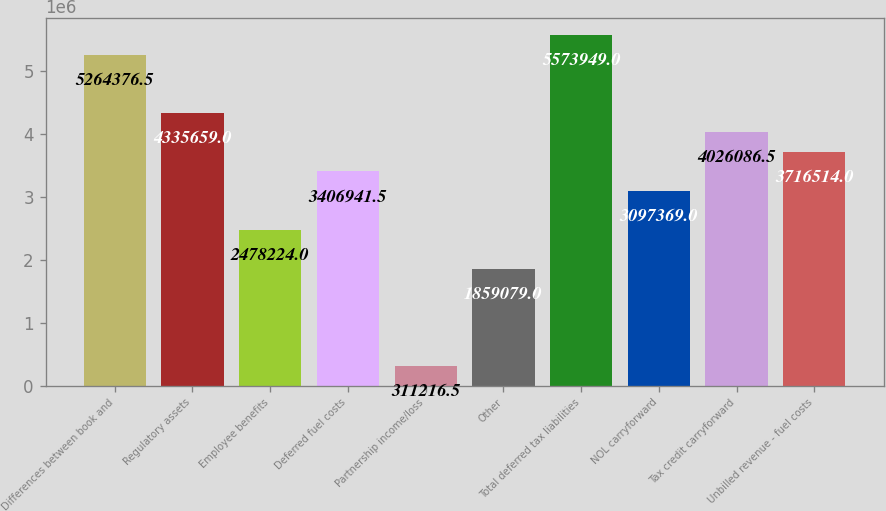Convert chart. <chart><loc_0><loc_0><loc_500><loc_500><bar_chart><fcel>Differences between book and<fcel>Regulatory assets<fcel>Employee benefits<fcel>Deferred fuel costs<fcel>Partnership income/loss<fcel>Other<fcel>Total deferred tax liabilities<fcel>NOL carryforward<fcel>Tax credit carryforward<fcel>Unbilled revenue - fuel costs<nl><fcel>5.26438e+06<fcel>4.33566e+06<fcel>2.47822e+06<fcel>3.40694e+06<fcel>311216<fcel>1.85908e+06<fcel>5.57395e+06<fcel>3.09737e+06<fcel>4.02609e+06<fcel>3.71651e+06<nl></chart> 